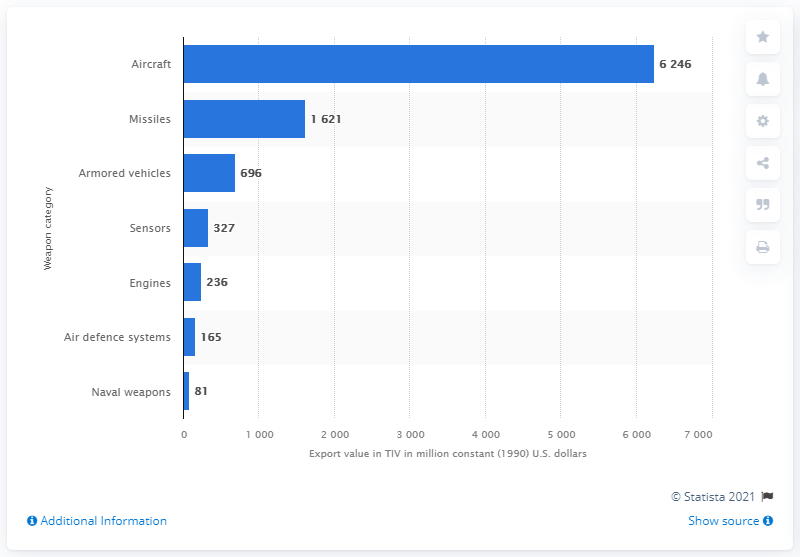Highlight a few significant elements in this photo. In 1990, the total value of US arms exports of armored vehicles was 696 million constant US dollars. 